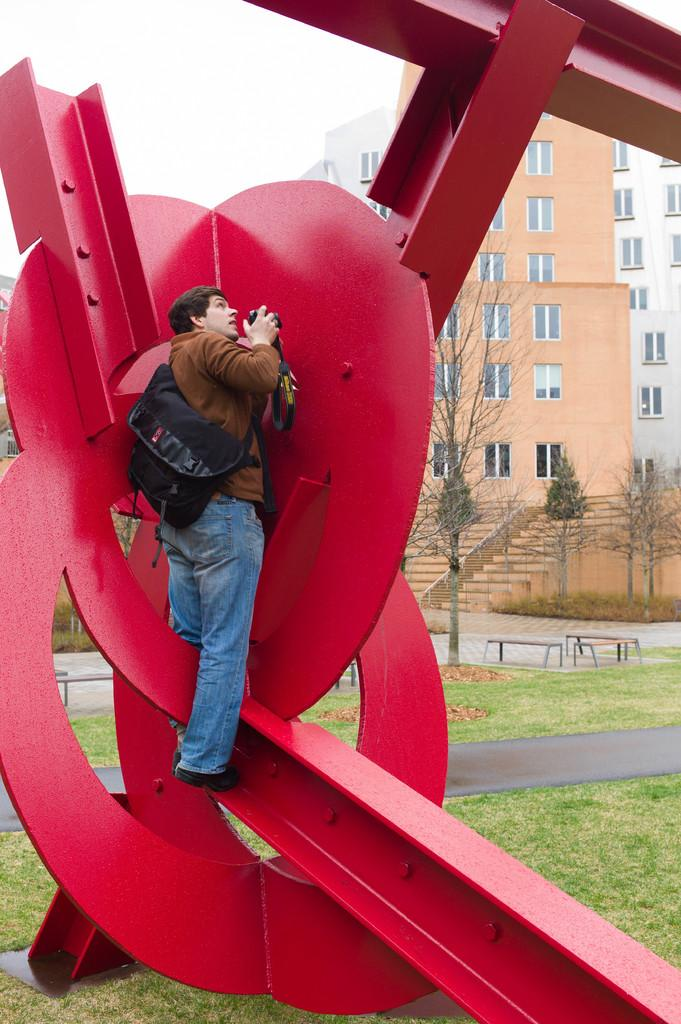Who is the main subject in the image? There is a man in the center of the image. What is the man holding in the image? The man is holding a camera. Where is the man located in the image? The man is on a statue. What can be seen in the background of the image? There are buildings, trees, benches, grass, a road, and the sky visible in the background of the image. What type of pot is the man using to take pictures in the image? There is no pot present in the image; the man is holding a camera. Can you see a knife in the man's hand in the image? No, there is no knife visible in the image; the man is holding a camera. 